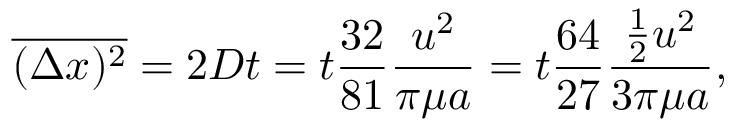<formula> <loc_0><loc_0><loc_500><loc_500>{ \overline { { ( \Delta x ) ^ { 2 } } } } = 2 D t = t { \frac { 3 2 } { 8 1 } } { \frac { u ^ { 2 } } { \pi \mu a } } = t { \frac { 6 4 } { 2 7 } } { \frac { { \frac { 1 } { 2 } } u ^ { 2 } } { 3 \pi \mu a } } ,</formula> 